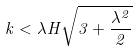<formula> <loc_0><loc_0><loc_500><loc_500>k < \lambda H \sqrt { 3 + \frac { \lambda ^ { 2 } } { 2 } }</formula> 